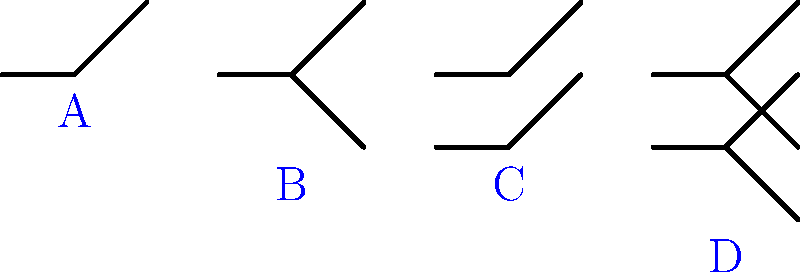In the schematic diagram above, which symbol represents a Double Pole Double Throw (DPDT) switch? To identify the Double Pole Double Throw (DPDT) switch, let's examine each symbol:

1. Symbol A: This is a Single Pole Single Throw (SPST) switch. It has one input and one output.

2. Symbol B: This is a Single Pole Double Throw (SPDT) switch. It has one input and two possible outputs.

3. Symbol C: This is a Double Pole Single Throw (DPST) switch. It has two separate inputs, each with a single output.

4. Symbol D: This is the Double Pole Double Throw (DPDT) switch we're looking for. It has:
   - Two separate inputs (double pole)
   - Each input has two possible outputs (double throw)
   - The symbol shows two SPDT switches linked together

The DPDT switch (Symbol D) is commonly used in applications where you need to switch two separate circuits simultaneously, each with two possible positions.
Answer: D 